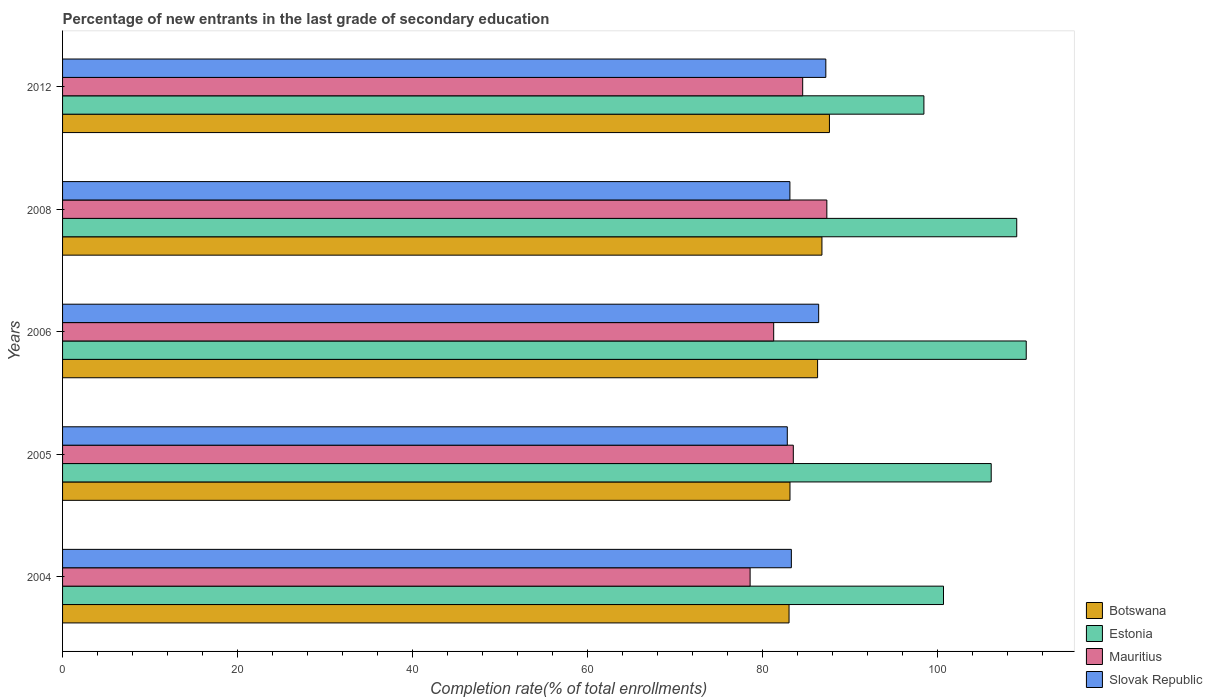How many different coloured bars are there?
Provide a short and direct response. 4. Are the number of bars on each tick of the Y-axis equal?
Your answer should be compact. Yes. How many bars are there on the 5th tick from the bottom?
Your answer should be very brief. 4. What is the label of the 1st group of bars from the top?
Offer a terse response. 2012. What is the percentage of new entrants in Botswana in 2004?
Ensure brevity in your answer.  83.02. Across all years, what is the maximum percentage of new entrants in Slovak Republic?
Your answer should be very brief. 87.23. Across all years, what is the minimum percentage of new entrants in Slovak Republic?
Your answer should be compact. 82.82. In which year was the percentage of new entrants in Botswana maximum?
Give a very brief answer. 2012. What is the total percentage of new entrants in Estonia in the graph?
Provide a succinct answer. 524.41. What is the difference between the percentage of new entrants in Estonia in 2004 and that in 2006?
Offer a terse response. -9.46. What is the difference between the percentage of new entrants in Mauritius in 2005 and the percentage of new entrants in Slovak Republic in 2012?
Your response must be concise. -3.72. What is the average percentage of new entrants in Slovak Republic per year?
Your answer should be compact. 84.57. In the year 2004, what is the difference between the percentage of new entrants in Estonia and percentage of new entrants in Mauritius?
Keep it short and to the point. 22.1. In how many years, is the percentage of new entrants in Estonia greater than 64 %?
Provide a succinct answer. 5. What is the ratio of the percentage of new entrants in Slovak Republic in 2006 to that in 2008?
Make the answer very short. 1.04. Is the percentage of new entrants in Botswana in 2004 less than that in 2008?
Provide a succinct answer. Yes. Is the difference between the percentage of new entrants in Estonia in 2006 and 2012 greater than the difference between the percentage of new entrants in Mauritius in 2006 and 2012?
Provide a short and direct response. Yes. What is the difference between the highest and the second highest percentage of new entrants in Mauritius?
Your response must be concise. 2.76. What is the difference between the highest and the lowest percentage of new entrants in Botswana?
Your response must be concise. 4.62. Is the sum of the percentage of new entrants in Estonia in 2005 and 2008 greater than the maximum percentage of new entrants in Mauritius across all years?
Your answer should be very brief. Yes. Is it the case that in every year, the sum of the percentage of new entrants in Botswana and percentage of new entrants in Estonia is greater than the sum of percentage of new entrants in Slovak Republic and percentage of new entrants in Mauritius?
Your answer should be compact. Yes. What does the 2nd bar from the top in 2012 represents?
Offer a very short reply. Mauritius. What does the 3rd bar from the bottom in 2006 represents?
Your answer should be very brief. Mauritius. How many years are there in the graph?
Make the answer very short. 5. How are the legend labels stacked?
Ensure brevity in your answer.  Vertical. What is the title of the graph?
Ensure brevity in your answer.  Percentage of new entrants in the last grade of secondary education. What is the label or title of the X-axis?
Offer a very short reply. Completion rate(% of total enrollments). What is the Completion rate(% of total enrollments) in Botswana in 2004?
Offer a terse response. 83.02. What is the Completion rate(% of total enrollments) in Estonia in 2004?
Offer a terse response. 100.67. What is the Completion rate(% of total enrollments) of Mauritius in 2004?
Your answer should be very brief. 78.57. What is the Completion rate(% of total enrollments) of Slovak Republic in 2004?
Your answer should be very brief. 83.29. What is the Completion rate(% of total enrollments) in Botswana in 2005?
Provide a succinct answer. 83.13. What is the Completion rate(% of total enrollments) in Estonia in 2005?
Give a very brief answer. 106.13. What is the Completion rate(% of total enrollments) in Mauritius in 2005?
Your answer should be compact. 83.51. What is the Completion rate(% of total enrollments) of Slovak Republic in 2005?
Provide a short and direct response. 82.82. What is the Completion rate(% of total enrollments) of Botswana in 2006?
Your answer should be compact. 86.29. What is the Completion rate(% of total enrollments) in Estonia in 2006?
Your answer should be very brief. 110.13. What is the Completion rate(% of total enrollments) of Mauritius in 2006?
Keep it short and to the point. 81.27. What is the Completion rate(% of total enrollments) in Slovak Republic in 2006?
Provide a short and direct response. 86.41. What is the Completion rate(% of total enrollments) in Botswana in 2008?
Give a very brief answer. 86.78. What is the Completion rate(% of total enrollments) in Estonia in 2008?
Provide a short and direct response. 109.04. What is the Completion rate(% of total enrollments) in Mauritius in 2008?
Ensure brevity in your answer.  87.34. What is the Completion rate(% of total enrollments) of Slovak Republic in 2008?
Give a very brief answer. 83.12. What is the Completion rate(% of total enrollments) in Botswana in 2012?
Your answer should be compact. 87.64. What is the Completion rate(% of total enrollments) of Estonia in 2012?
Give a very brief answer. 98.43. What is the Completion rate(% of total enrollments) in Mauritius in 2012?
Make the answer very short. 84.58. What is the Completion rate(% of total enrollments) of Slovak Republic in 2012?
Offer a very short reply. 87.23. Across all years, what is the maximum Completion rate(% of total enrollments) of Botswana?
Your answer should be very brief. 87.64. Across all years, what is the maximum Completion rate(% of total enrollments) in Estonia?
Keep it short and to the point. 110.13. Across all years, what is the maximum Completion rate(% of total enrollments) of Mauritius?
Make the answer very short. 87.34. Across all years, what is the maximum Completion rate(% of total enrollments) in Slovak Republic?
Your response must be concise. 87.23. Across all years, what is the minimum Completion rate(% of total enrollments) in Botswana?
Provide a succinct answer. 83.02. Across all years, what is the minimum Completion rate(% of total enrollments) in Estonia?
Provide a short and direct response. 98.43. Across all years, what is the minimum Completion rate(% of total enrollments) of Mauritius?
Offer a very short reply. 78.57. Across all years, what is the minimum Completion rate(% of total enrollments) in Slovak Republic?
Ensure brevity in your answer.  82.82. What is the total Completion rate(% of total enrollments) in Botswana in the graph?
Your answer should be very brief. 426.86. What is the total Completion rate(% of total enrollments) in Estonia in the graph?
Your answer should be very brief. 524.41. What is the total Completion rate(% of total enrollments) in Mauritius in the graph?
Give a very brief answer. 415.28. What is the total Completion rate(% of total enrollments) of Slovak Republic in the graph?
Give a very brief answer. 422.87. What is the difference between the Completion rate(% of total enrollments) in Botswana in 2004 and that in 2005?
Provide a succinct answer. -0.11. What is the difference between the Completion rate(% of total enrollments) in Estonia in 2004 and that in 2005?
Provide a short and direct response. -5.45. What is the difference between the Completion rate(% of total enrollments) of Mauritius in 2004 and that in 2005?
Your answer should be very brief. -4.94. What is the difference between the Completion rate(% of total enrollments) in Slovak Republic in 2004 and that in 2005?
Make the answer very short. 0.46. What is the difference between the Completion rate(% of total enrollments) of Botswana in 2004 and that in 2006?
Provide a succinct answer. -3.26. What is the difference between the Completion rate(% of total enrollments) in Estonia in 2004 and that in 2006?
Ensure brevity in your answer.  -9.46. What is the difference between the Completion rate(% of total enrollments) of Mauritius in 2004 and that in 2006?
Give a very brief answer. -2.69. What is the difference between the Completion rate(% of total enrollments) in Slovak Republic in 2004 and that in 2006?
Make the answer very short. -3.12. What is the difference between the Completion rate(% of total enrollments) of Botswana in 2004 and that in 2008?
Offer a terse response. -3.76. What is the difference between the Completion rate(% of total enrollments) of Estonia in 2004 and that in 2008?
Offer a terse response. -8.37. What is the difference between the Completion rate(% of total enrollments) in Mauritius in 2004 and that in 2008?
Offer a terse response. -8.77. What is the difference between the Completion rate(% of total enrollments) of Slovak Republic in 2004 and that in 2008?
Provide a short and direct response. 0.16. What is the difference between the Completion rate(% of total enrollments) of Botswana in 2004 and that in 2012?
Make the answer very short. -4.62. What is the difference between the Completion rate(% of total enrollments) of Estonia in 2004 and that in 2012?
Offer a very short reply. 2.24. What is the difference between the Completion rate(% of total enrollments) of Mauritius in 2004 and that in 2012?
Make the answer very short. -6.01. What is the difference between the Completion rate(% of total enrollments) of Slovak Republic in 2004 and that in 2012?
Offer a terse response. -3.94. What is the difference between the Completion rate(% of total enrollments) in Botswana in 2005 and that in 2006?
Your response must be concise. -3.15. What is the difference between the Completion rate(% of total enrollments) in Estonia in 2005 and that in 2006?
Provide a succinct answer. -4. What is the difference between the Completion rate(% of total enrollments) of Mauritius in 2005 and that in 2006?
Keep it short and to the point. 2.24. What is the difference between the Completion rate(% of total enrollments) in Slovak Republic in 2005 and that in 2006?
Provide a succinct answer. -3.59. What is the difference between the Completion rate(% of total enrollments) in Botswana in 2005 and that in 2008?
Make the answer very short. -3.65. What is the difference between the Completion rate(% of total enrollments) in Estonia in 2005 and that in 2008?
Provide a short and direct response. -2.92. What is the difference between the Completion rate(% of total enrollments) of Mauritius in 2005 and that in 2008?
Provide a succinct answer. -3.83. What is the difference between the Completion rate(% of total enrollments) in Slovak Republic in 2005 and that in 2008?
Offer a terse response. -0.3. What is the difference between the Completion rate(% of total enrollments) of Botswana in 2005 and that in 2012?
Provide a short and direct response. -4.51. What is the difference between the Completion rate(% of total enrollments) of Estonia in 2005 and that in 2012?
Ensure brevity in your answer.  7.69. What is the difference between the Completion rate(% of total enrollments) in Mauritius in 2005 and that in 2012?
Your response must be concise. -1.07. What is the difference between the Completion rate(% of total enrollments) of Slovak Republic in 2005 and that in 2012?
Offer a very short reply. -4.4. What is the difference between the Completion rate(% of total enrollments) in Botswana in 2006 and that in 2008?
Your response must be concise. -0.5. What is the difference between the Completion rate(% of total enrollments) in Estonia in 2006 and that in 2008?
Keep it short and to the point. 1.08. What is the difference between the Completion rate(% of total enrollments) of Mauritius in 2006 and that in 2008?
Your answer should be compact. -6.08. What is the difference between the Completion rate(% of total enrollments) of Slovak Republic in 2006 and that in 2008?
Your answer should be compact. 3.29. What is the difference between the Completion rate(% of total enrollments) in Botswana in 2006 and that in 2012?
Give a very brief answer. -1.35. What is the difference between the Completion rate(% of total enrollments) of Estonia in 2006 and that in 2012?
Keep it short and to the point. 11.69. What is the difference between the Completion rate(% of total enrollments) of Mauritius in 2006 and that in 2012?
Make the answer very short. -3.31. What is the difference between the Completion rate(% of total enrollments) in Slovak Republic in 2006 and that in 2012?
Provide a succinct answer. -0.82. What is the difference between the Completion rate(% of total enrollments) in Botswana in 2008 and that in 2012?
Provide a succinct answer. -0.86. What is the difference between the Completion rate(% of total enrollments) in Estonia in 2008 and that in 2012?
Your response must be concise. 10.61. What is the difference between the Completion rate(% of total enrollments) in Mauritius in 2008 and that in 2012?
Make the answer very short. 2.76. What is the difference between the Completion rate(% of total enrollments) of Slovak Republic in 2008 and that in 2012?
Ensure brevity in your answer.  -4.11. What is the difference between the Completion rate(% of total enrollments) of Botswana in 2004 and the Completion rate(% of total enrollments) of Estonia in 2005?
Offer a terse response. -23.1. What is the difference between the Completion rate(% of total enrollments) in Botswana in 2004 and the Completion rate(% of total enrollments) in Mauritius in 2005?
Offer a very short reply. -0.49. What is the difference between the Completion rate(% of total enrollments) in Botswana in 2004 and the Completion rate(% of total enrollments) in Slovak Republic in 2005?
Provide a succinct answer. 0.2. What is the difference between the Completion rate(% of total enrollments) of Estonia in 2004 and the Completion rate(% of total enrollments) of Mauritius in 2005?
Your answer should be compact. 17.16. What is the difference between the Completion rate(% of total enrollments) in Estonia in 2004 and the Completion rate(% of total enrollments) in Slovak Republic in 2005?
Your response must be concise. 17.85. What is the difference between the Completion rate(% of total enrollments) of Mauritius in 2004 and the Completion rate(% of total enrollments) of Slovak Republic in 2005?
Provide a short and direct response. -4.25. What is the difference between the Completion rate(% of total enrollments) of Botswana in 2004 and the Completion rate(% of total enrollments) of Estonia in 2006?
Make the answer very short. -27.11. What is the difference between the Completion rate(% of total enrollments) of Botswana in 2004 and the Completion rate(% of total enrollments) of Mauritius in 2006?
Your answer should be very brief. 1.76. What is the difference between the Completion rate(% of total enrollments) in Botswana in 2004 and the Completion rate(% of total enrollments) in Slovak Republic in 2006?
Ensure brevity in your answer.  -3.39. What is the difference between the Completion rate(% of total enrollments) of Estonia in 2004 and the Completion rate(% of total enrollments) of Mauritius in 2006?
Offer a very short reply. 19.41. What is the difference between the Completion rate(% of total enrollments) in Estonia in 2004 and the Completion rate(% of total enrollments) in Slovak Republic in 2006?
Provide a short and direct response. 14.26. What is the difference between the Completion rate(% of total enrollments) in Mauritius in 2004 and the Completion rate(% of total enrollments) in Slovak Republic in 2006?
Provide a short and direct response. -7.83. What is the difference between the Completion rate(% of total enrollments) in Botswana in 2004 and the Completion rate(% of total enrollments) in Estonia in 2008?
Give a very brief answer. -26.02. What is the difference between the Completion rate(% of total enrollments) in Botswana in 2004 and the Completion rate(% of total enrollments) in Mauritius in 2008?
Give a very brief answer. -4.32. What is the difference between the Completion rate(% of total enrollments) in Botswana in 2004 and the Completion rate(% of total enrollments) in Slovak Republic in 2008?
Give a very brief answer. -0.1. What is the difference between the Completion rate(% of total enrollments) in Estonia in 2004 and the Completion rate(% of total enrollments) in Mauritius in 2008?
Ensure brevity in your answer.  13.33. What is the difference between the Completion rate(% of total enrollments) of Estonia in 2004 and the Completion rate(% of total enrollments) of Slovak Republic in 2008?
Your response must be concise. 17.55. What is the difference between the Completion rate(% of total enrollments) in Mauritius in 2004 and the Completion rate(% of total enrollments) in Slovak Republic in 2008?
Keep it short and to the point. -4.55. What is the difference between the Completion rate(% of total enrollments) of Botswana in 2004 and the Completion rate(% of total enrollments) of Estonia in 2012?
Provide a short and direct response. -15.41. What is the difference between the Completion rate(% of total enrollments) of Botswana in 2004 and the Completion rate(% of total enrollments) of Mauritius in 2012?
Your answer should be very brief. -1.56. What is the difference between the Completion rate(% of total enrollments) of Botswana in 2004 and the Completion rate(% of total enrollments) of Slovak Republic in 2012?
Give a very brief answer. -4.2. What is the difference between the Completion rate(% of total enrollments) in Estonia in 2004 and the Completion rate(% of total enrollments) in Mauritius in 2012?
Provide a short and direct response. 16.09. What is the difference between the Completion rate(% of total enrollments) in Estonia in 2004 and the Completion rate(% of total enrollments) in Slovak Republic in 2012?
Your answer should be very brief. 13.45. What is the difference between the Completion rate(% of total enrollments) of Mauritius in 2004 and the Completion rate(% of total enrollments) of Slovak Republic in 2012?
Keep it short and to the point. -8.65. What is the difference between the Completion rate(% of total enrollments) in Botswana in 2005 and the Completion rate(% of total enrollments) in Estonia in 2006?
Provide a succinct answer. -27. What is the difference between the Completion rate(% of total enrollments) of Botswana in 2005 and the Completion rate(% of total enrollments) of Mauritius in 2006?
Provide a succinct answer. 1.86. What is the difference between the Completion rate(% of total enrollments) of Botswana in 2005 and the Completion rate(% of total enrollments) of Slovak Republic in 2006?
Offer a terse response. -3.28. What is the difference between the Completion rate(% of total enrollments) of Estonia in 2005 and the Completion rate(% of total enrollments) of Mauritius in 2006?
Offer a terse response. 24.86. What is the difference between the Completion rate(% of total enrollments) of Estonia in 2005 and the Completion rate(% of total enrollments) of Slovak Republic in 2006?
Your answer should be very brief. 19.72. What is the difference between the Completion rate(% of total enrollments) in Mauritius in 2005 and the Completion rate(% of total enrollments) in Slovak Republic in 2006?
Make the answer very short. -2.9. What is the difference between the Completion rate(% of total enrollments) of Botswana in 2005 and the Completion rate(% of total enrollments) of Estonia in 2008?
Ensure brevity in your answer.  -25.91. What is the difference between the Completion rate(% of total enrollments) of Botswana in 2005 and the Completion rate(% of total enrollments) of Mauritius in 2008?
Provide a succinct answer. -4.21. What is the difference between the Completion rate(% of total enrollments) in Botswana in 2005 and the Completion rate(% of total enrollments) in Slovak Republic in 2008?
Keep it short and to the point. 0.01. What is the difference between the Completion rate(% of total enrollments) in Estonia in 2005 and the Completion rate(% of total enrollments) in Mauritius in 2008?
Offer a terse response. 18.78. What is the difference between the Completion rate(% of total enrollments) in Estonia in 2005 and the Completion rate(% of total enrollments) in Slovak Republic in 2008?
Make the answer very short. 23. What is the difference between the Completion rate(% of total enrollments) in Mauritius in 2005 and the Completion rate(% of total enrollments) in Slovak Republic in 2008?
Ensure brevity in your answer.  0.39. What is the difference between the Completion rate(% of total enrollments) in Botswana in 2005 and the Completion rate(% of total enrollments) in Estonia in 2012?
Give a very brief answer. -15.3. What is the difference between the Completion rate(% of total enrollments) of Botswana in 2005 and the Completion rate(% of total enrollments) of Mauritius in 2012?
Offer a terse response. -1.45. What is the difference between the Completion rate(% of total enrollments) of Botswana in 2005 and the Completion rate(% of total enrollments) of Slovak Republic in 2012?
Your response must be concise. -4.1. What is the difference between the Completion rate(% of total enrollments) in Estonia in 2005 and the Completion rate(% of total enrollments) in Mauritius in 2012?
Offer a very short reply. 21.54. What is the difference between the Completion rate(% of total enrollments) of Estonia in 2005 and the Completion rate(% of total enrollments) of Slovak Republic in 2012?
Your answer should be compact. 18.9. What is the difference between the Completion rate(% of total enrollments) in Mauritius in 2005 and the Completion rate(% of total enrollments) in Slovak Republic in 2012?
Your answer should be compact. -3.72. What is the difference between the Completion rate(% of total enrollments) in Botswana in 2006 and the Completion rate(% of total enrollments) in Estonia in 2008?
Provide a short and direct response. -22.76. What is the difference between the Completion rate(% of total enrollments) of Botswana in 2006 and the Completion rate(% of total enrollments) of Mauritius in 2008?
Ensure brevity in your answer.  -1.06. What is the difference between the Completion rate(% of total enrollments) of Botswana in 2006 and the Completion rate(% of total enrollments) of Slovak Republic in 2008?
Give a very brief answer. 3.16. What is the difference between the Completion rate(% of total enrollments) of Estonia in 2006 and the Completion rate(% of total enrollments) of Mauritius in 2008?
Offer a terse response. 22.79. What is the difference between the Completion rate(% of total enrollments) in Estonia in 2006 and the Completion rate(% of total enrollments) in Slovak Republic in 2008?
Your response must be concise. 27.01. What is the difference between the Completion rate(% of total enrollments) of Mauritius in 2006 and the Completion rate(% of total enrollments) of Slovak Republic in 2008?
Give a very brief answer. -1.85. What is the difference between the Completion rate(% of total enrollments) of Botswana in 2006 and the Completion rate(% of total enrollments) of Estonia in 2012?
Offer a very short reply. -12.15. What is the difference between the Completion rate(% of total enrollments) of Botswana in 2006 and the Completion rate(% of total enrollments) of Mauritius in 2012?
Offer a terse response. 1.7. What is the difference between the Completion rate(% of total enrollments) of Botswana in 2006 and the Completion rate(% of total enrollments) of Slovak Republic in 2012?
Provide a succinct answer. -0.94. What is the difference between the Completion rate(% of total enrollments) of Estonia in 2006 and the Completion rate(% of total enrollments) of Mauritius in 2012?
Make the answer very short. 25.55. What is the difference between the Completion rate(% of total enrollments) of Estonia in 2006 and the Completion rate(% of total enrollments) of Slovak Republic in 2012?
Offer a very short reply. 22.9. What is the difference between the Completion rate(% of total enrollments) of Mauritius in 2006 and the Completion rate(% of total enrollments) of Slovak Republic in 2012?
Your answer should be compact. -5.96. What is the difference between the Completion rate(% of total enrollments) of Botswana in 2008 and the Completion rate(% of total enrollments) of Estonia in 2012?
Your response must be concise. -11.65. What is the difference between the Completion rate(% of total enrollments) in Botswana in 2008 and the Completion rate(% of total enrollments) in Mauritius in 2012?
Give a very brief answer. 2.2. What is the difference between the Completion rate(% of total enrollments) of Botswana in 2008 and the Completion rate(% of total enrollments) of Slovak Republic in 2012?
Give a very brief answer. -0.45. What is the difference between the Completion rate(% of total enrollments) of Estonia in 2008 and the Completion rate(% of total enrollments) of Mauritius in 2012?
Give a very brief answer. 24.46. What is the difference between the Completion rate(% of total enrollments) of Estonia in 2008 and the Completion rate(% of total enrollments) of Slovak Republic in 2012?
Keep it short and to the point. 21.82. What is the difference between the Completion rate(% of total enrollments) in Mauritius in 2008 and the Completion rate(% of total enrollments) in Slovak Republic in 2012?
Offer a terse response. 0.12. What is the average Completion rate(% of total enrollments) of Botswana per year?
Your answer should be very brief. 85.37. What is the average Completion rate(% of total enrollments) in Estonia per year?
Keep it short and to the point. 104.88. What is the average Completion rate(% of total enrollments) of Mauritius per year?
Offer a terse response. 83.06. What is the average Completion rate(% of total enrollments) in Slovak Republic per year?
Ensure brevity in your answer.  84.57. In the year 2004, what is the difference between the Completion rate(% of total enrollments) of Botswana and Completion rate(% of total enrollments) of Estonia?
Offer a terse response. -17.65. In the year 2004, what is the difference between the Completion rate(% of total enrollments) of Botswana and Completion rate(% of total enrollments) of Mauritius?
Offer a terse response. 4.45. In the year 2004, what is the difference between the Completion rate(% of total enrollments) in Botswana and Completion rate(% of total enrollments) in Slovak Republic?
Ensure brevity in your answer.  -0.26. In the year 2004, what is the difference between the Completion rate(% of total enrollments) of Estonia and Completion rate(% of total enrollments) of Mauritius?
Offer a very short reply. 22.1. In the year 2004, what is the difference between the Completion rate(% of total enrollments) in Estonia and Completion rate(% of total enrollments) in Slovak Republic?
Your answer should be compact. 17.39. In the year 2004, what is the difference between the Completion rate(% of total enrollments) in Mauritius and Completion rate(% of total enrollments) in Slovak Republic?
Provide a short and direct response. -4.71. In the year 2005, what is the difference between the Completion rate(% of total enrollments) of Botswana and Completion rate(% of total enrollments) of Estonia?
Offer a terse response. -23. In the year 2005, what is the difference between the Completion rate(% of total enrollments) of Botswana and Completion rate(% of total enrollments) of Mauritius?
Give a very brief answer. -0.38. In the year 2005, what is the difference between the Completion rate(% of total enrollments) of Botswana and Completion rate(% of total enrollments) of Slovak Republic?
Offer a terse response. 0.31. In the year 2005, what is the difference between the Completion rate(% of total enrollments) in Estonia and Completion rate(% of total enrollments) in Mauritius?
Offer a terse response. 22.62. In the year 2005, what is the difference between the Completion rate(% of total enrollments) of Estonia and Completion rate(% of total enrollments) of Slovak Republic?
Ensure brevity in your answer.  23.3. In the year 2005, what is the difference between the Completion rate(% of total enrollments) of Mauritius and Completion rate(% of total enrollments) of Slovak Republic?
Ensure brevity in your answer.  0.69. In the year 2006, what is the difference between the Completion rate(% of total enrollments) in Botswana and Completion rate(% of total enrollments) in Estonia?
Your answer should be compact. -23.84. In the year 2006, what is the difference between the Completion rate(% of total enrollments) in Botswana and Completion rate(% of total enrollments) in Mauritius?
Give a very brief answer. 5.02. In the year 2006, what is the difference between the Completion rate(% of total enrollments) in Botswana and Completion rate(% of total enrollments) in Slovak Republic?
Give a very brief answer. -0.12. In the year 2006, what is the difference between the Completion rate(% of total enrollments) in Estonia and Completion rate(% of total enrollments) in Mauritius?
Keep it short and to the point. 28.86. In the year 2006, what is the difference between the Completion rate(% of total enrollments) of Estonia and Completion rate(% of total enrollments) of Slovak Republic?
Provide a short and direct response. 23.72. In the year 2006, what is the difference between the Completion rate(% of total enrollments) in Mauritius and Completion rate(% of total enrollments) in Slovak Republic?
Your response must be concise. -5.14. In the year 2008, what is the difference between the Completion rate(% of total enrollments) of Botswana and Completion rate(% of total enrollments) of Estonia?
Provide a succinct answer. -22.26. In the year 2008, what is the difference between the Completion rate(% of total enrollments) in Botswana and Completion rate(% of total enrollments) in Mauritius?
Your response must be concise. -0.56. In the year 2008, what is the difference between the Completion rate(% of total enrollments) of Botswana and Completion rate(% of total enrollments) of Slovak Republic?
Provide a short and direct response. 3.66. In the year 2008, what is the difference between the Completion rate(% of total enrollments) of Estonia and Completion rate(% of total enrollments) of Mauritius?
Offer a very short reply. 21.7. In the year 2008, what is the difference between the Completion rate(% of total enrollments) in Estonia and Completion rate(% of total enrollments) in Slovak Republic?
Offer a very short reply. 25.92. In the year 2008, what is the difference between the Completion rate(% of total enrollments) in Mauritius and Completion rate(% of total enrollments) in Slovak Republic?
Your answer should be very brief. 4.22. In the year 2012, what is the difference between the Completion rate(% of total enrollments) in Botswana and Completion rate(% of total enrollments) in Estonia?
Provide a short and direct response. -10.8. In the year 2012, what is the difference between the Completion rate(% of total enrollments) in Botswana and Completion rate(% of total enrollments) in Mauritius?
Your response must be concise. 3.06. In the year 2012, what is the difference between the Completion rate(% of total enrollments) in Botswana and Completion rate(% of total enrollments) in Slovak Republic?
Offer a very short reply. 0.41. In the year 2012, what is the difference between the Completion rate(% of total enrollments) of Estonia and Completion rate(% of total enrollments) of Mauritius?
Your answer should be very brief. 13.85. In the year 2012, what is the difference between the Completion rate(% of total enrollments) in Estonia and Completion rate(% of total enrollments) in Slovak Republic?
Offer a terse response. 11.21. In the year 2012, what is the difference between the Completion rate(% of total enrollments) of Mauritius and Completion rate(% of total enrollments) of Slovak Republic?
Keep it short and to the point. -2.65. What is the ratio of the Completion rate(% of total enrollments) of Botswana in 2004 to that in 2005?
Make the answer very short. 1. What is the ratio of the Completion rate(% of total enrollments) of Estonia in 2004 to that in 2005?
Provide a short and direct response. 0.95. What is the ratio of the Completion rate(% of total enrollments) of Mauritius in 2004 to that in 2005?
Offer a very short reply. 0.94. What is the ratio of the Completion rate(% of total enrollments) of Slovak Republic in 2004 to that in 2005?
Your response must be concise. 1.01. What is the ratio of the Completion rate(% of total enrollments) of Botswana in 2004 to that in 2006?
Offer a terse response. 0.96. What is the ratio of the Completion rate(% of total enrollments) in Estonia in 2004 to that in 2006?
Offer a terse response. 0.91. What is the ratio of the Completion rate(% of total enrollments) of Mauritius in 2004 to that in 2006?
Provide a short and direct response. 0.97. What is the ratio of the Completion rate(% of total enrollments) of Slovak Republic in 2004 to that in 2006?
Keep it short and to the point. 0.96. What is the ratio of the Completion rate(% of total enrollments) in Botswana in 2004 to that in 2008?
Your answer should be compact. 0.96. What is the ratio of the Completion rate(% of total enrollments) of Estonia in 2004 to that in 2008?
Make the answer very short. 0.92. What is the ratio of the Completion rate(% of total enrollments) of Mauritius in 2004 to that in 2008?
Provide a short and direct response. 0.9. What is the ratio of the Completion rate(% of total enrollments) in Slovak Republic in 2004 to that in 2008?
Provide a short and direct response. 1. What is the ratio of the Completion rate(% of total enrollments) in Botswana in 2004 to that in 2012?
Your answer should be compact. 0.95. What is the ratio of the Completion rate(% of total enrollments) of Estonia in 2004 to that in 2012?
Offer a very short reply. 1.02. What is the ratio of the Completion rate(% of total enrollments) in Mauritius in 2004 to that in 2012?
Offer a very short reply. 0.93. What is the ratio of the Completion rate(% of total enrollments) of Slovak Republic in 2004 to that in 2012?
Make the answer very short. 0.95. What is the ratio of the Completion rate(% of total enrollments) of Botswana in 2005 to that in 2006?
Keep it short and to the point. 0.96. What is the ratio of the Completion rate(% of total enrollments) in Estonia in 2005 to that in 2006?
Ensure brevity in your answer.  0.96. What is the ratio of the Completion rate(% of total enrollments) in Mauritius in 2005 to that in 2006?
Your answer should be compact. 1.03. What is the ratio of the Completion rate(% of total enrollments) in Slovak Republic in 2005 to that in 2006?
Provide a succinct answer. 0.96. What is the ratio of the Completion rate(% of total enrollments) in Botswana in 2005 to that in 2008?
Your response must be concise. 0.96. What is the ratio of the Completion rate(% of total enrollments) in Estonia in 2005 to that in 2008?
Offer a very short reply. 0.97. What is the ratio of the Completion rate(% of total enrollments) in Mauritius in 2005 to that in 2008?
Make the answer very short. 0.96. What is the ratio of the Completion rate(% of total enrollments) in Botswana in 2005 to that in 2012?
Keep it short and to the point. 0.95. What is the ratio of the Completion rate(% of total enrollments) in Estonia in 2005 to that in 2012?
Provide a short and direct response. 1.08. What is the ratio of the Completion rate(% of total enrollments) in Mauritius in 2005 to that in 2012?
Your answer should be very brief. 0.99. What is the ratio of the Completion rate(% of total enrollments) of Slovak Republic in 2005 to that in 2012?
Your answer should be compact. 0.95. What is the ratio of the Completion rate(% of total enrollments) of Botswana in 2006 to that in 2008?
Ensure brevity in your answer.  0.99. What is the ratio of the Completion rate(% of total enrollments) in Estonia in 2006 to that in 2008?
Your response must be concise. 1.01. What is the ratio of the Completion rate(% of total enrollments) of Mauritius in 2006 to that in 2008?
Provide a short and direct response. 0.93. What is the ratio of the Completion rate(% of total enrollments) of Slovak Republic in 2006 to that in 2008?
Your response must be concise. 1.04. What is the ratio of the Completion rate(% of total enrollments) in Botswana in 2006 to that in 2012?
Offer a terse response. 0.98. What is the ratio of the Completion rate(% of total enrollments) of Estonia in 2006 to that in 2012?
Offer a terse response. 1.12. What is the ratio of the Completion rate(% of total enrollments) in Mauritius in 2006 to that in 2012?
Keep it short and to the point. 0.96. What is the ratio of the Completion rate(% of total enrollments) of Slovak Republic in 2006 to that in 2012?
Keep it short and to the point. 0.99. What is the ratio of the Completion rate(% of total enrollments) in Botswana in 2008 to that in 2012?
Your answer should be compact. 0.99. What is the ratio of the Completion rate(% of total enrollments) in Estonia in 2008 to that in 2012?
Offer a terse response. 1.11. What is the ratio of the Completion rate(% of total enrollments) of Mauritius in 2008 to that in 2012?
Offer a terse response. 1.03. What is the ratio of the Completion rate(% of total enrollments) of Slovak Republic in 2008 to that in 2012?
Give a very brief answer. 0.95. What is the difference between the highest and the second highest Completion rate(% of total enrollments) of Botswana?
Make the answer very short. 0.86. What is the difference between the highest and the second highest Completion rate(% of total enrollments) in Estonia?
Offer a terse response. 1.08. What is the difference between the highest and the second highest Completion rate(% of total enrollments) of Mauritius?
Offer a terse response. 2.76. What is the difference between the highest and the second highest Completion rate(% of total enrollments) in Slovak Republic?
Offer a very short reply. 0.82. What is the difference between the highest and the lowest Completion rate(% of total enrollments) of Botswana?
Keep it short and to the point. 4.62. What is the difference between the highest and the lowest Completion rate(% of total enrollments) of Estonia?
Provide a succinct answer. 11.69. What is the difference between the highest and the lowest Completion rate(% of total enrollments) in Mauritius?
Provide a short and direct response. 8.77. What is the difference between the highest and the lowest Completion rate(% of total enrollments) in Slovak Republic?
Your answer should be compact. 4.4. 